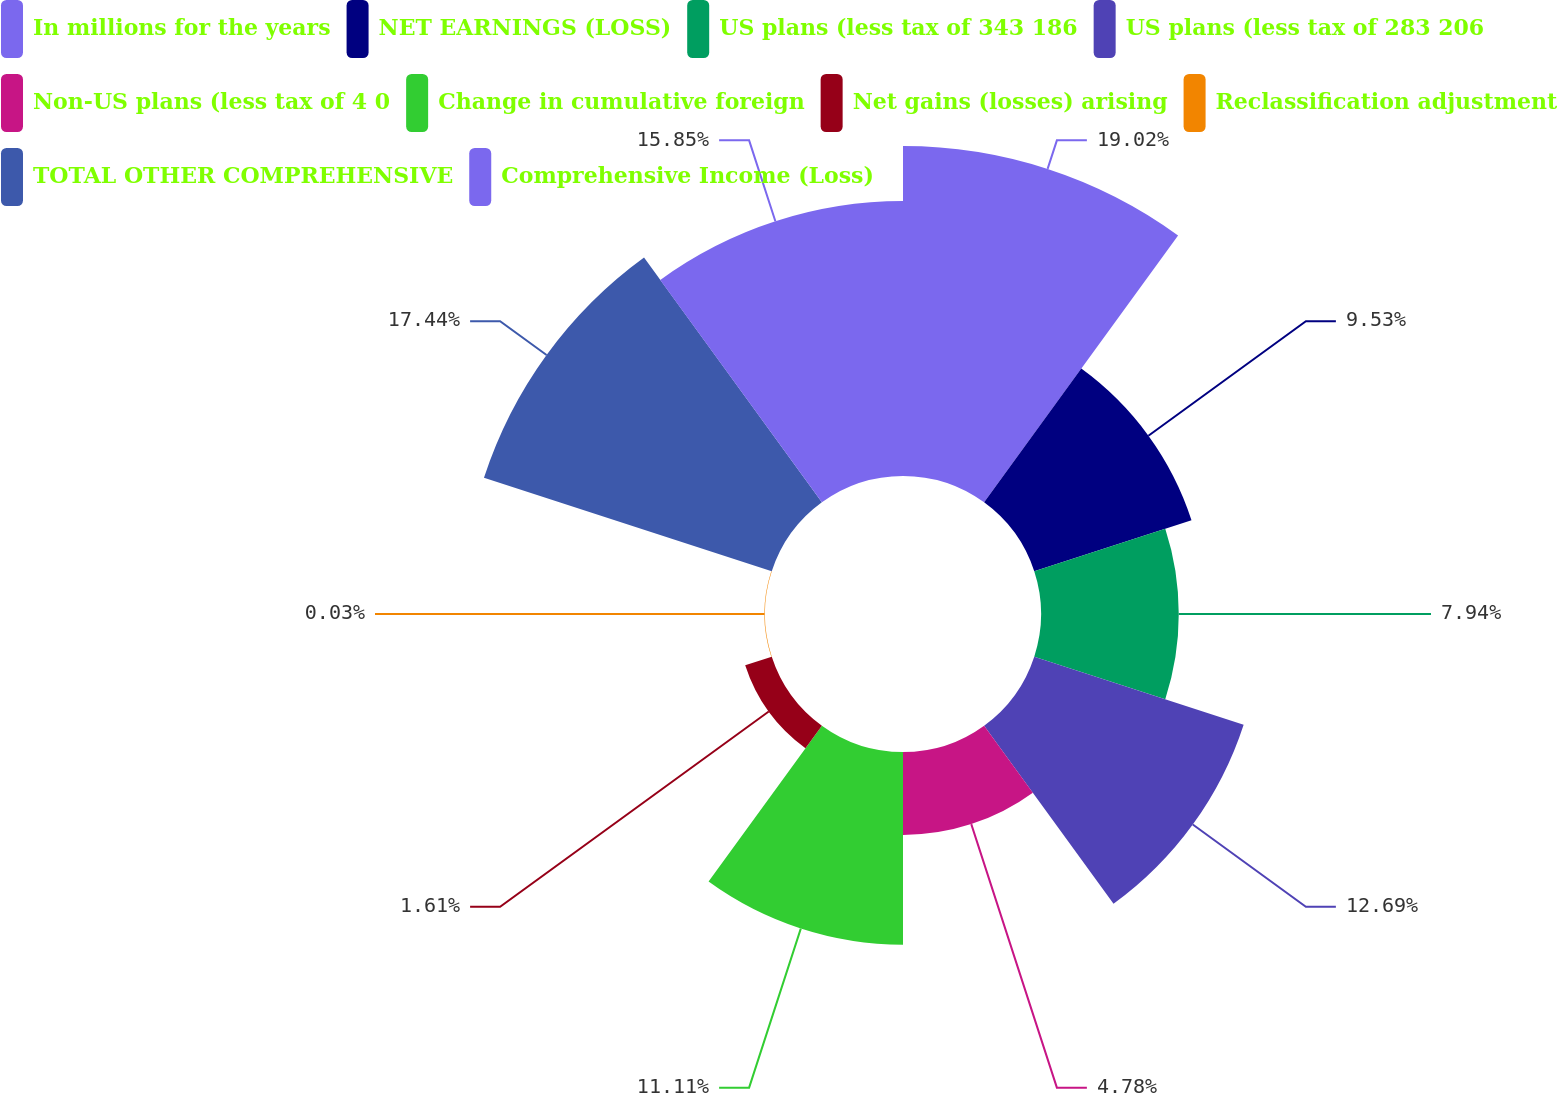Convert chart to OTSL. <chart><loc_0><loc_0><loc_500><loc_500><pie_chart><fcel>In millions for the years<fcel>NET EARNINGS (LOSS)<fcel>US plans (less tax of 343 186<fcel>US plans (less tax of 283 206<fcel>Non-US plans (less tax of 4 0<fcel>Change in cumulative foreign<fcel>Net gains (losses) arising<fcel>Reclassification adjustment<fcel>TOTAL OTHER COMPREHENSIVE<fcel>Comprehensive Income (Loss)<nl><fcel>19.02%<fcel>9.53%<fcel>7.94%<fcel>12.69%<fcel>4.78%<fcel>11.11%<fcel>1.61%<fcel>0.03%<fcel>17.44%<fcel>15.85%<nl></chart> 